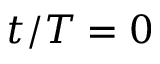Convert formula to latex. <formula><loc_0><loc_0><loc_500><loc_500>t / T = 0</formula> 